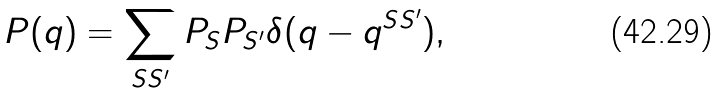Convert formula to latex. <formula><loc_0><loc_0><loc_500><loc_500>P ( q ) = \sum _ { S S ^ { \prime } } P _ { S } P _ { S ^ { \prime } } \delta ( q - q ^ { S S ^ { \prime } } ) ,</formula> 